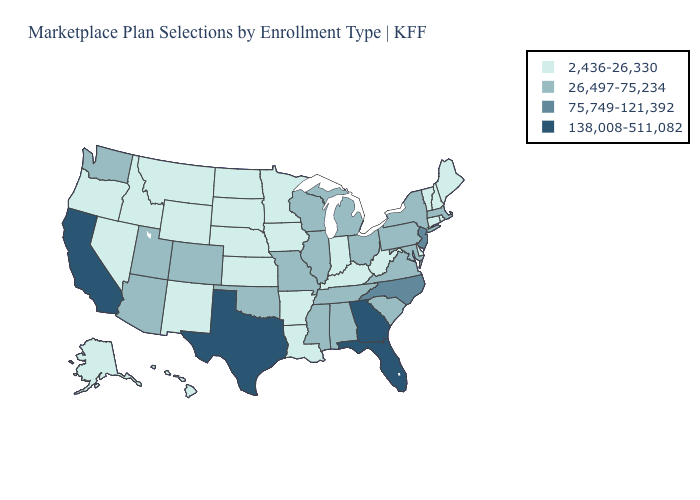Which states have the lowest value in the South?
Concise answer only. Arkansas, Delaware, Kentucky, Louisiana, West Virginia. Name the states that have a value in the range 2,436-26,330?
Quick response, please. Alaska, Arkansas, Connecticut, Delaware, Hawaii, Idaho, Indiana, Iowa, Kansas, Kentucky, Louisiana, Maine, Minnesota, Montana, Nebraska, Nevada, New Hampshire, New Mexico, North Dakota, Oregon, Rhode Island, South Dakota, Vermont, West Virginia, Wyoming. Does the map have missing data?
Quick response, please. No. Among the states that border Iowa , which have the lowest value?
Give a very brief answer. Minnesota, Nebraska, South Dakota. Among the states that border Vermont , which have the lowest value?
Keep it brief. New Hampshire. Is the legend a continuous bar?
Short answer required. No. How many symbols are there in the legend?
Answer briefly. 4. Name the states that have a value in the range 26,497-75,234?
Answer briefly. Alabama, Arizona, Colorado, Illinois, Maryland, Massachusetts, Michigan, Mississippi, Missouri, New York, Ohio, Oklahoma, Pennsylvania, South Carolina, Tennessee, Utah, Virginia, Washington, Wisconsin. What is the value of Minnesota?
Write a very short answer. 2,436-26,330. Does South Carolina have the lowest value in the USA?
Be succinct. No. What is the value of Michigan?
Keep it brief. 26,497-75,234. Does Pennsylvania have the highest value in the Northeast?
Keep it brief. No. Among the states that border Maine , which have the lowest value?
Be succinct. New Hampshire. What is the value of Hawaii?
Concise answer only. 2,436-26,330. Does Colorado have the lowest value in the West?
Be succinct. No. 